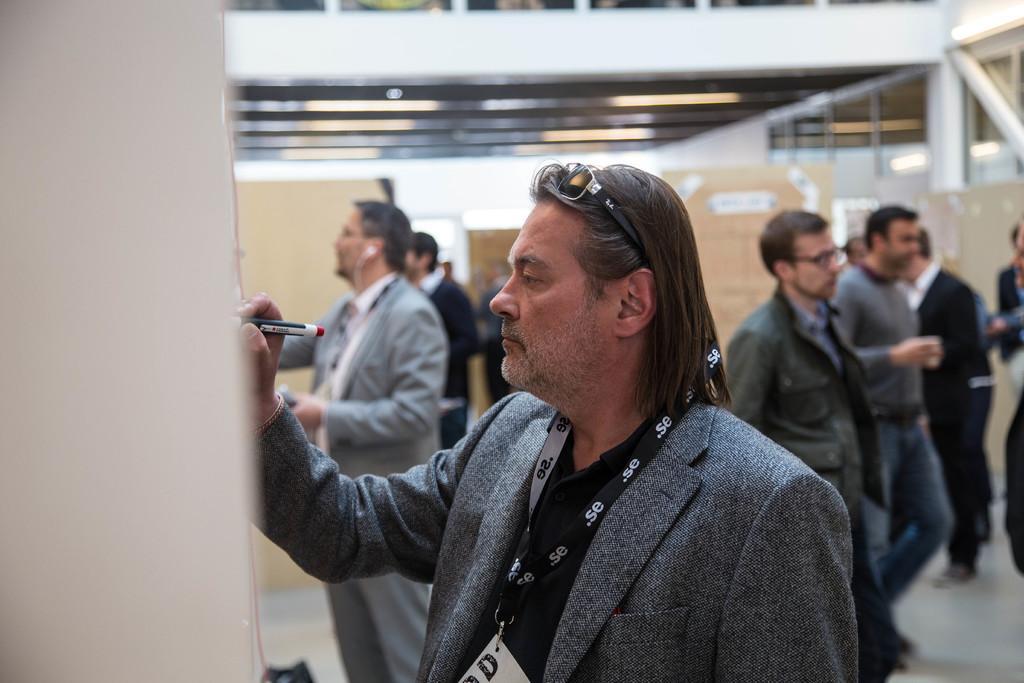Describe this image in one or two sentences. In the image,there are few men. In the front the first man is writing something with a marker he is wearing a blazer and goggles and the background of these people is blur. 